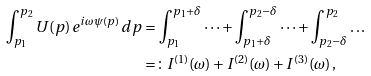<formula> <loc_0><loc_0><loc_500><loc_500>\int _ { p _ { 1 } } ^ { p _ { 2 } } U ( p ) \, e ^ { i \omega \psi ( p ) } \, d p & = \int _ { p _ { 1 } } ^ { p _ { 1 } + \delta } \dots + \int _ { p _ { 1 } + \delta } ^ { p _ { 2 } - \delta } \dots + \int _ { p _ { 2 } - \delta } ^ { p _ { 2 } } \dots \\ & = \colon I ^ { ( 1 ) } ( \omega ) + I ^ { ( 2 ) } ( \omega ) + I ^ { ( 3 ) } ( \omega ) \, ,</formula> 